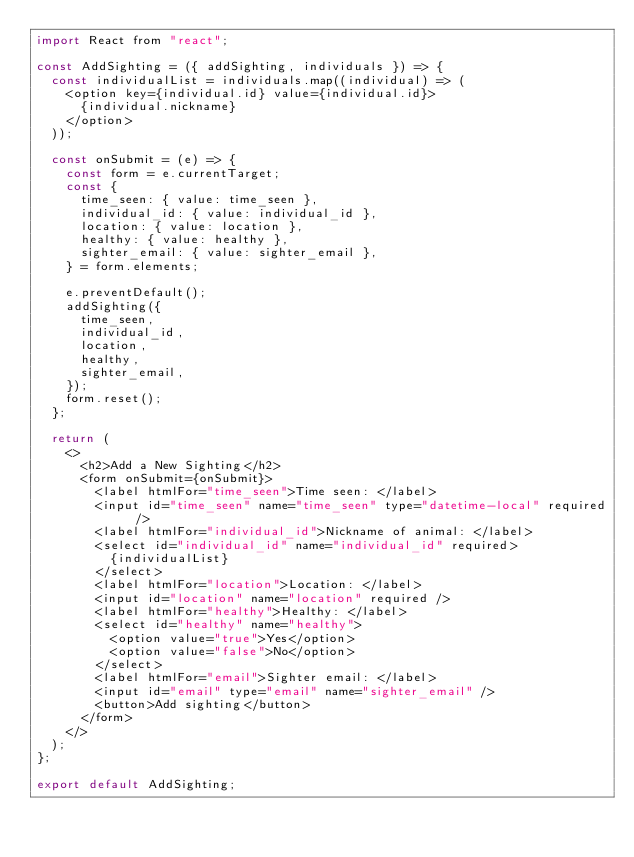<code> <loc_0><loc_0><loc_500><loc_500><_JavaScript_>import React from "react";

const AddSighting = ({ addSighting, individuals }) => {
  const individualList = individuals.map((individual) => (
    <option key={individual.id} value={individual.id}>
      {individual.nickname}
    </option>
  ));

  const onSubmit = (e) => {
    const form = e.currentTarget;
    const {
      time_seen: { value: time_seen },
      individual_id: { value: individual_id },
      location: { value: location },
      healthy: { value: healthy },
      sighter_email: { value: sighter_email },
    } = form.elements;

    e.preventDefault();
    addSighting({
      time_seen,
      individual_id,
      location,
      healthy,
      sighter_email,
    });
    form.reset();
  };

  return (
    <>
      <h2>Add a New Sighting</h2>
      <form onSubmit={onSubmit}>
        <label htmlFor="time_seen">Time seen: </label>
        <input id="time_seen" name="time_seen" type="datetime-local" required />
        <label htmlFor="individual_id">Nickname of animal: </label>
        <select id="individual_id" name="individual_id" required>
          {individualList}
        </select>
        <label htmlFor="location">Location: </label>
        <input id="location" name="location" required />
        <label htmlFor="healthy">Healthy: </label>
        <select id="healthy" name="healthy">
          <option value="true">Yes</option>
          <option value="false">No</option>
        </select>
        <label htmlFor="email">Sighter email: </label>
        <input id="email" type="email" name="sighter_email" />
        <button>Add sighting</button>
      </form>
    </>
  );
};

export default AddSighting;
</code> 